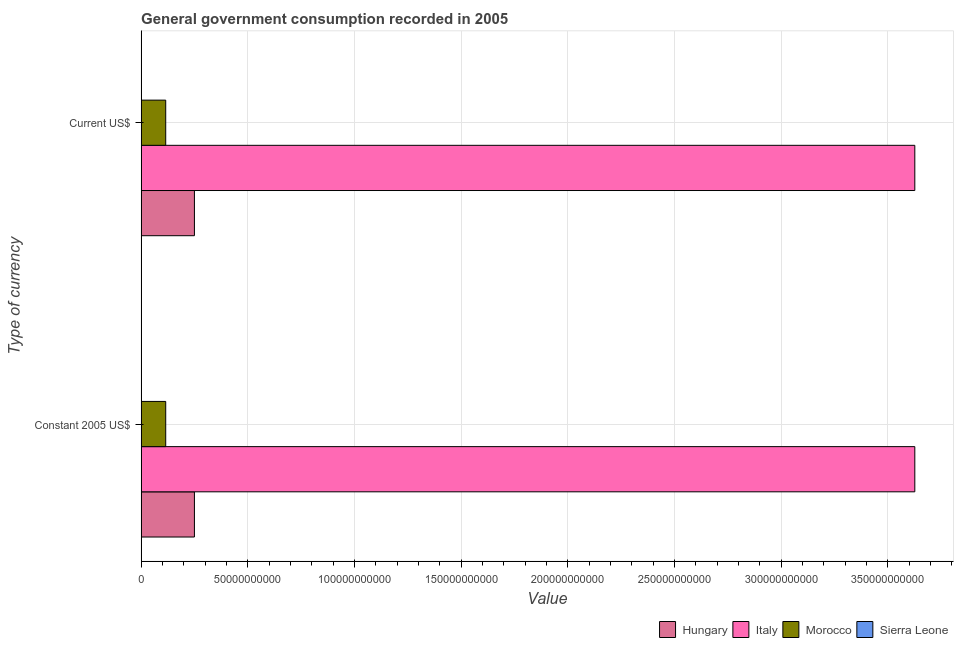Are the number of bars per tick equal to the number of legend labels?
Ensure brevity in your answer.  Yes. Are the number of bars on each tick of the Y-axis equal?
Your answer should be very brief. Yes. What is the label of the 1st group of bars from the top?
Offer a terse response. Current US$. What is the value consumed in constant 2005 us$ in Sierra Leone?
Ensure brevity in your answer.  1.63e+08. Across all countries, what is the maximum value consumed in current us$?
Your answer should be compact. 3.63e+11. Across all countries, what is the minimum value consumed in current us$?
Offer a terse response. 1.63e+08. In which country was the value consumed in constant 2005 us$ minimum?
Your response must be concise. Sierra Leone. What is the total value consumed in current us$ in the graph?
Ensure brevity in your answer.  3.99e+11. What is the difference between the value consumed in constant 2005 us$ in Morocco and that in Italy?
Offer a terse response. -3.51e+11. What is the difference between the value consumed in current us$ in Morocco and the value consumed in constant 2005 us$ in Sierra Leone?
Your answer should be compact. 1.14e+1. What is the average value consumed in current us$ per country?
Keep it short and to the point. 9.98e+1. What is the difference between the value consumed in current us$ and value consumed in constant 2005 us$ in Italy?
Your response must be concise. 0. What is the ratio of the value consumed in current us$ in Hungary to that in Sierra Leone?
Keep it short and to the point. 153.03. Is the value consumed in current us$ in Morocco less than that in Sierra Leone?
Your answer should be very brief. No. In how many countries, is the value consumed in constant 2005 us$ greater than the average value consumed in constant 2005 us$ taken over all countries?
Keep it short and to the point. 1. What does the 2nd bar from the top in Constant 2005 US$ represents?
Give a very brief answer. Morocco. What does the 3rd bar from the bottom in Constant 2005 US$ represents?
Make the answer very short. Morocco. Are the values on the major ticks of X-axis written in scientific E-notation?
Make the answer very short. No. Does the graph contain any zero values?
Offer a very short reply. No. Does the graph contain grids?
Offer a very short reply. Yes. What is the title of the graph?
Keep it short and to the point. General government consumption recorded in 2005. Does "Aruba" appear as one of the legend labels in the graph?
Your response must be concise. No. What is the label or title of the X-axis?
Offer a very short reply. Value. What is the label or title of the Y-axis?
Offer a very short reply. Type of currency. What is the Value of Hungary in Constant 2005 US$?
Keep it short and to the point. 2.50e+1. What is the Value in Italy in Constant 2005 US$?
Ensure brevity in your answer.  3.63e+11. What is the Value in Morocco in Constant 2005 US$?
Ensure brevity in your answer.  1.15e+1. What is the Value in Sierra Leone in Constant 2005 US$?
Your answer should be compact. 1.63e+08. What is the Value in Hungary in Current US$?
Give a very brief answer. 2.50e+1. What is the Value in Italy in Current US$?
Provide a short and direct response. 3.63e+11. What is the Value in Morocco in Current US$?
Provide a succinct answer. 1.15e+1. What is the Value of Sierra Leone in Current US$?
Your response must be concise. 1.63e+08. Across all Type of currency, what is the maximum Value in Hungary?
Give a very brief answer. 2.50e+1. Across all Type of currency, what is the maximum Value of Italy?
Provide a succinct answer. 3.63e+11. Across all Type of currency, what is the maximum Value of Morocco?
Ensure brevity in your answer.  1.15e+1. Across all Type of currency, what is the maximum Value in Sierra Leone?
Ensure brevity in your answer.  1.63e+08. Across all Type of currency, what is the minimum Value in Hungary?
Offer a terse response. 2.50e+1. Across all Type of currency, what is the minimum Value of Italy?
Offer a terse response. 3.63e+11. Across all Type of currency, what is the minimum Value in Morocco?
Make the answer very short. 1.15e+1. Across all Type of currency, what is the minimum Value in Sierra Leone?
Make the answer very short. 1.63e+08. What is the total Value in Hungary in the graph?
Make the answer very short. 4.99e+1. What is the total Value of Italy in the graph?
Provide a short and direct response. 7.25e+11. What is the total Value in Morocco in the graph?
Keep it short and to the point. 2.30e+1. What is the total Value in Sierra Leone in the graph?
Provide a short and direct response. 3.26e+08. What is the difference between the Value in Hungary in Constant 2005 US$ and the Value in Italy in Current US$?
Make the answer very short. -3.38e+11. What is the difference between the Value of Hungary in Constant 2005 US$ and the Value of Morocco in Current US$?
Offer a terse response. 1.35e+1. What is the difference between the Value of Hungary in Constant 2005 US$ and the Value of Sierra Leone in Current US$?
Your response must be concise. 2.48e+1. What is the difference between the Value of Italy in Constant 2005 US$ and the Value of Morocco in Current US$?
Provide a short and direct response. 3.51e+11. What is the difference between the Value of Italy in Constant 2005 US$ and the Value of Sierra Leone in Current US$?
Give a very brief answer. 3.62e+11. What is the difference between the Value of Morocco in Constant 2005 US$ and the Value of Sierra Leone in Current US$?
Your answer should be very brief. 1.14e+1. What is the average Value in Hungary per Type of currency?
Give a very brief answer. 2.50e+1. What is the average Value in Italy per Type of currency?
Offer a very short reply. 3.63e+11. What is the average Value of Morocco per Type of currency?
Keep it short and to the point. 1.15e+1. What is the average Value in Sierra Leone per Type of currency?
Your response must be concise. 1.63e+08. What is the difference between the Value of Hungary and Value of Italy in Constant 2005 US$?
Your response must be concise. -3.38e+11. What is the difference between the Value of Hungary and Value of Morocco in Constant 2005 US$?
Your response must be concise. 1.35e+1. What is the difference between the Value in Hungary and Value in Sierra Leone in Constant 2005 US$?
Offer a terse response. 2.48e+1. What is the difference between the Value of Italy and Value of Morocco in Constant 2005 US$?
Ensure brevity in your answer.  3.51e+11. What is the difference between the Value of Italy and Value of Sierra Leone in Constant 2005 US$?
Offer a terse response. 3.62e+11. What is the difference between the Value in Morocco and Value in Sierra Leone in Constant 2005 US$?
Make the answer very short. 1.14e+1. What is the difference between the Value in Hungary and Value in Italy in Current US$?
Provide a succinct answer. -3.38e+11. What is the difference between the Value in Hungary and Value in Morocco in Current US$?
Make the answer very short. 1.35e+1. What is the difference between the Value in Hungary and Value in Sierra Leone in Current US$?
Keep it short and to the point. 2.48e+1. What is the difference between the Value in Italy and Value in Morocco in Current US$?
Make the answer very short. 3.51e+11. What is the difference between the Value in Italy and Value in Sierra Leone in Current US$?
Provide a short and direct response. 3.62e+11. What is the difference between the Value in Morocco and Value in Sierra Leone in Current US$?
Your response must be concise. 1.14e+1. What is the ratio of the Value in Morocco in Constant 2005 US$ to that in Current US$?
Make the answer very short. 1. What is the ratio of the Value in Sierra Leone in Constant 2005 US$ to that in Current US$?
Keep it short and to the point. 1. What is the difference between the highest and the second highest Value of Hungary?
Your response must be concise. 0. What is the difference between the highest and the second highest Value of Italy?
Offer a very short reply. 0. What is the difference between the highest and the lowest Value in Hungary?
Your response must be concise. 0. What is the difference between the highest and the lowest Value in Italy?
Your answer should be very brief. 0. What is the difference between the highest and the lowest Value in Morocco?
Offer a very short reply. 0. What is the difference between the highest and the lowest Value in Sierra Leone?
Offer a very short reply. 0. 